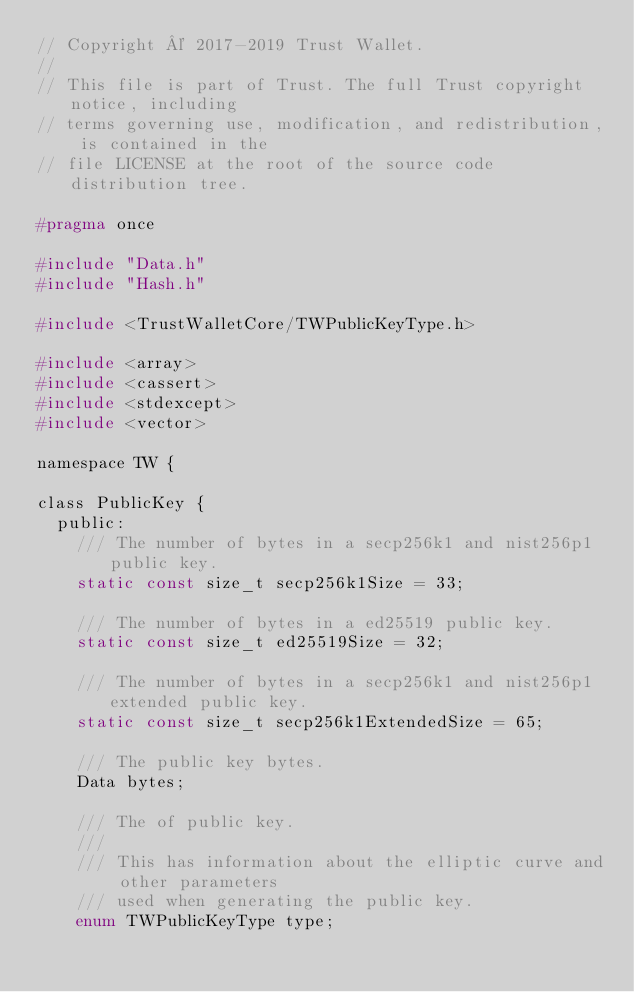Convert code to text. <code><loc_0><loc_0><loc_500><loc_500><_C_>// Copyright © 2017-2019 Trust Wallet.
//
// This file is part of Trust. The full Trust copyright notice, including
// terms governing use, modification, and redistribution, is contained in the
// file LICENSE at the root of the source code distribution tree.

#pragma once

#include "Data.h"
#include "Hash.h"

#include <TrustWalletCore/TWPublicKeyType.h>

#include <array>
#include <cassert>
#include <stdexcept>
#include <vector>

namespace TW {

class PublicKey {
  public:
    /// The number of bytes in a secp256k1 and nist256p1 public key.
    static const size_t secp256k1Size = 33;

    /// The number of bytes in a ed25519 public key.
    static const size_t ed25519Size = 32;

    /// The number of bytes in a secp256k1 and nist256p1 extended public key.
    static const size_t secp256k1ExtendedSize = 65;

    /// The public key bytes.
    Data bytes;

    /// The of public key.
    ///
    /// This has information about the elliptic curve and other parameters
    /// used when generating the public key.
    enum TWPublicKeyType type;
</code> 